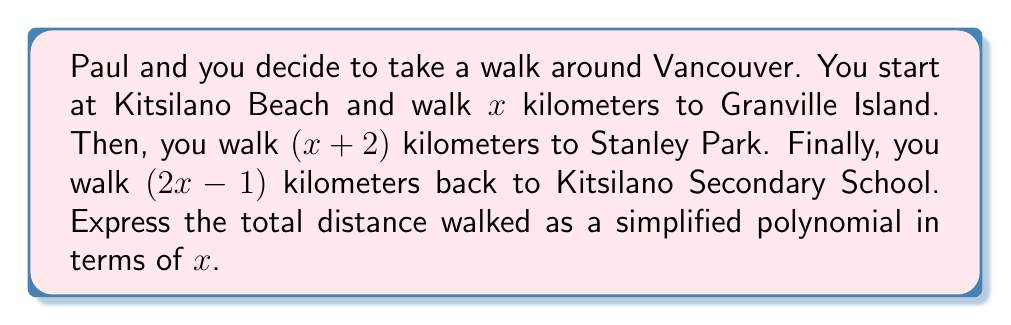Can you solve this math problem? Let's approach this step-by-step:

1) First, we need to add up all the distances:
   - Kitsilano Beach to Granville Island: $x$ km
   - Granville Island to Stanley Park: $(x+2)$ km
   - Stanley Park to Kitsilano Secondary School: $(2x-1)$ km

2) We can represent this as a sum:
   $$x + (x+2) + (2x-1)$$

3) Now, let's expand the brackets:
   $$x + x + 2 + 2x - 1$$

4) We can now combine like terms:
   - We have one $x$ from the first term, one $x$ from the second term, and $2x$ from the third term. This gives us $4x$ in total.
   - We have a constant term of 2 and another of -1. These sum to 1.

5) Therefore, our simplified polynomial is:
   $$4x + 1$$

This represents the total distance walked in kilometers, expressed as a polynomial in terms of $x$.
Answer: $4x + 1$ 